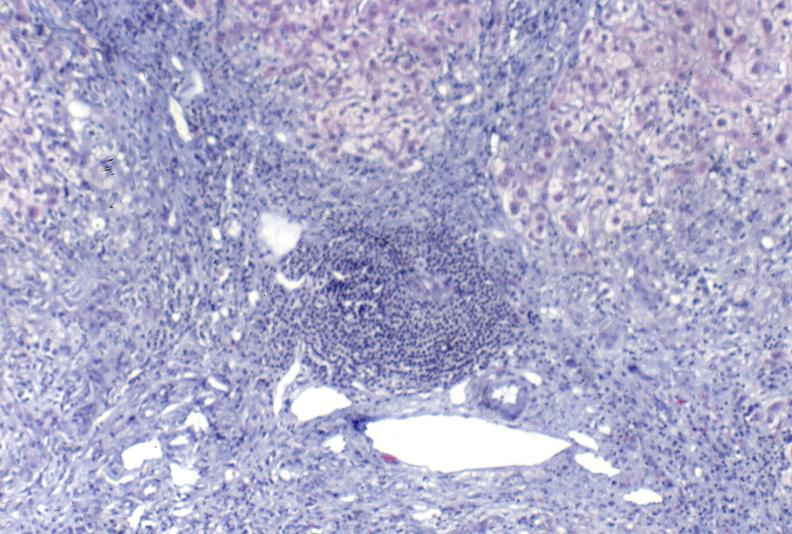what is present?
Answer the question using a single word or phrase. Hepatobiliary 